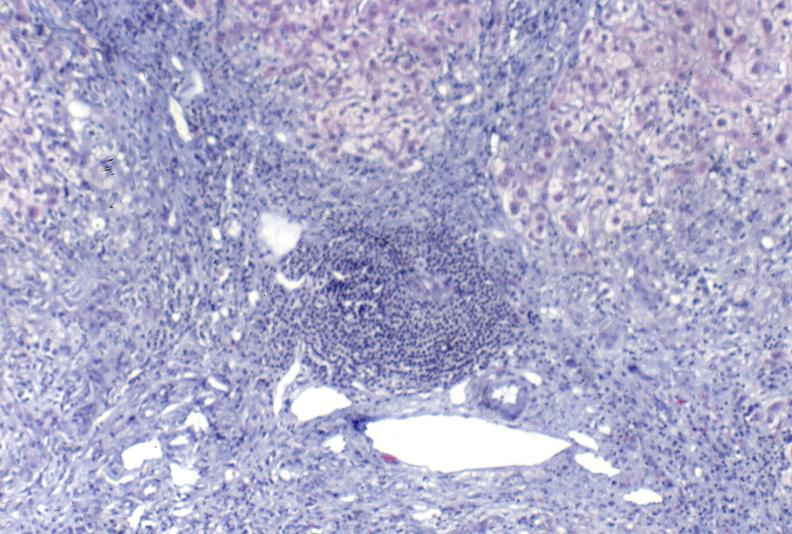what is present?
Answer the question using a single word or phrase. Hepatobiliary 